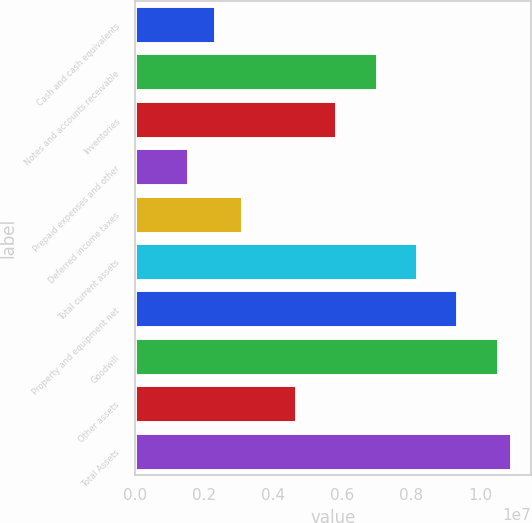<chart> <loc_0><loc_0><loc_500><loc_500><bar_chart><fcel>Cash and cash equivalents<fcel>Notes and accounts receivable<fcel>Inventories<fcel>Prepaid expenses and other<fcel>Deferred income taxes<fcel>Total current assets<fcel>Property and equipment net<fcel>Goodwill<fcel>Other assets<fcel>Total Assets<nl><fcel>2.3448e+06<fcel>7.03413e+06<fcel>5.8618e+06<fcel>1.56324e+06<fcel>3.12635e+06<fcel>8.20646e+06<fcel>9.3788e+06<fcel>1.05511e+07<fcel>4.68946e+06<fcel>1.09419e+07<nl></chart> 